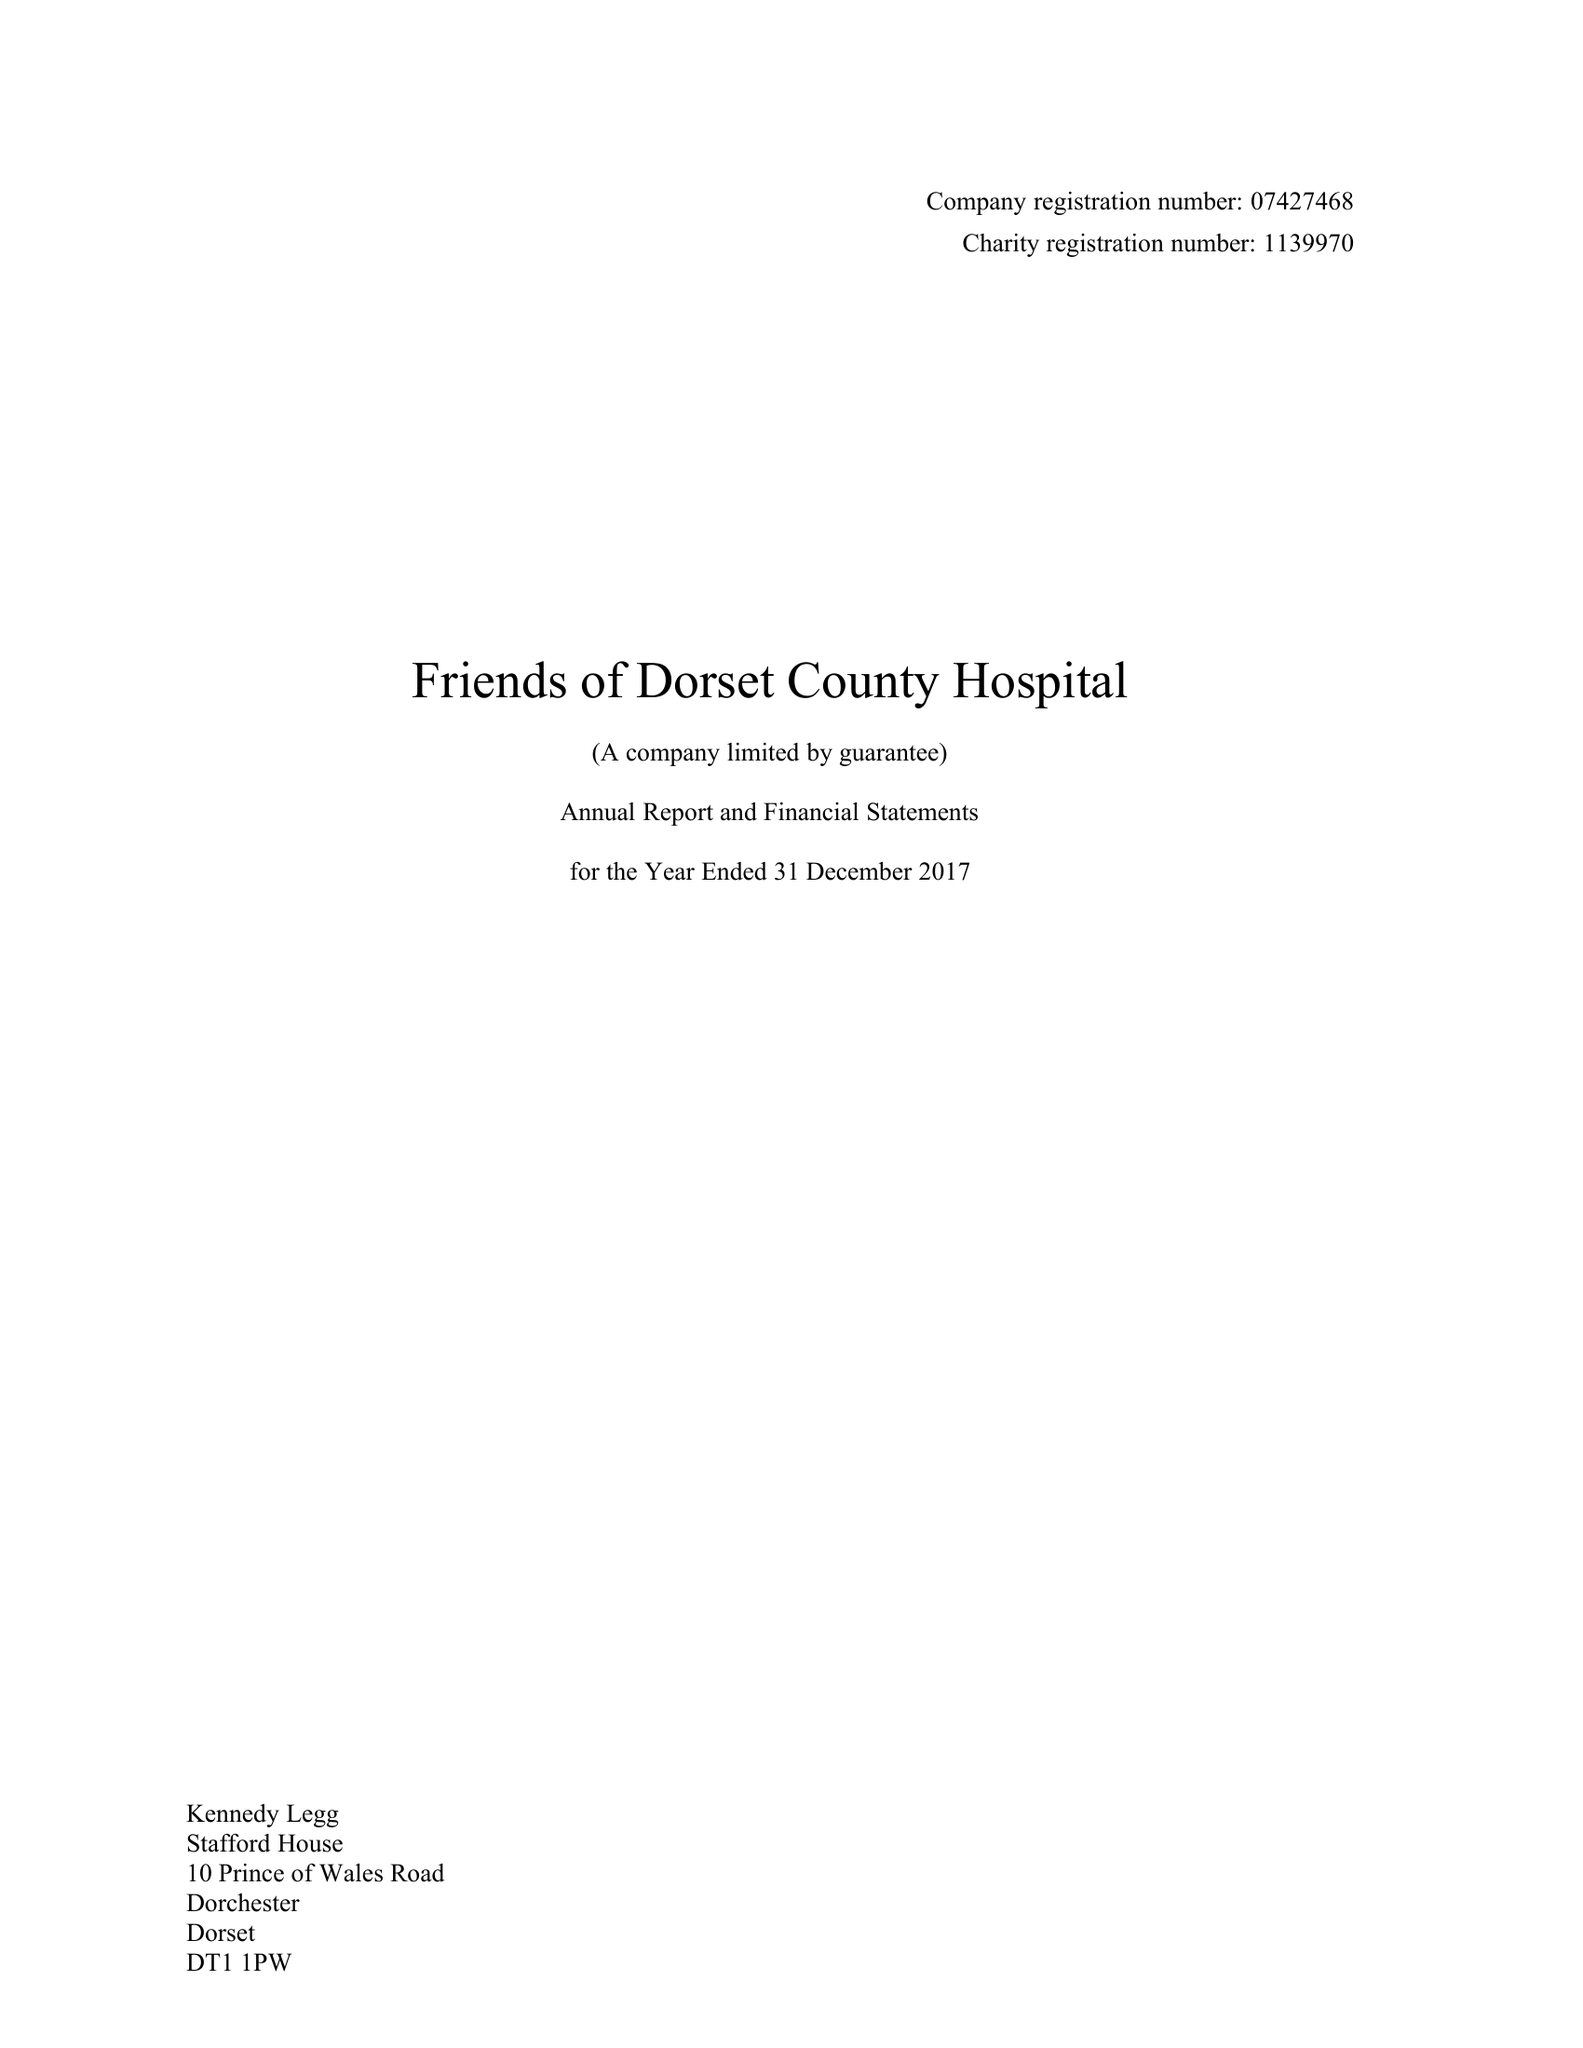What is the value for the address__postcode?
Answer the question using a single word or phrase. DT1 1PW 